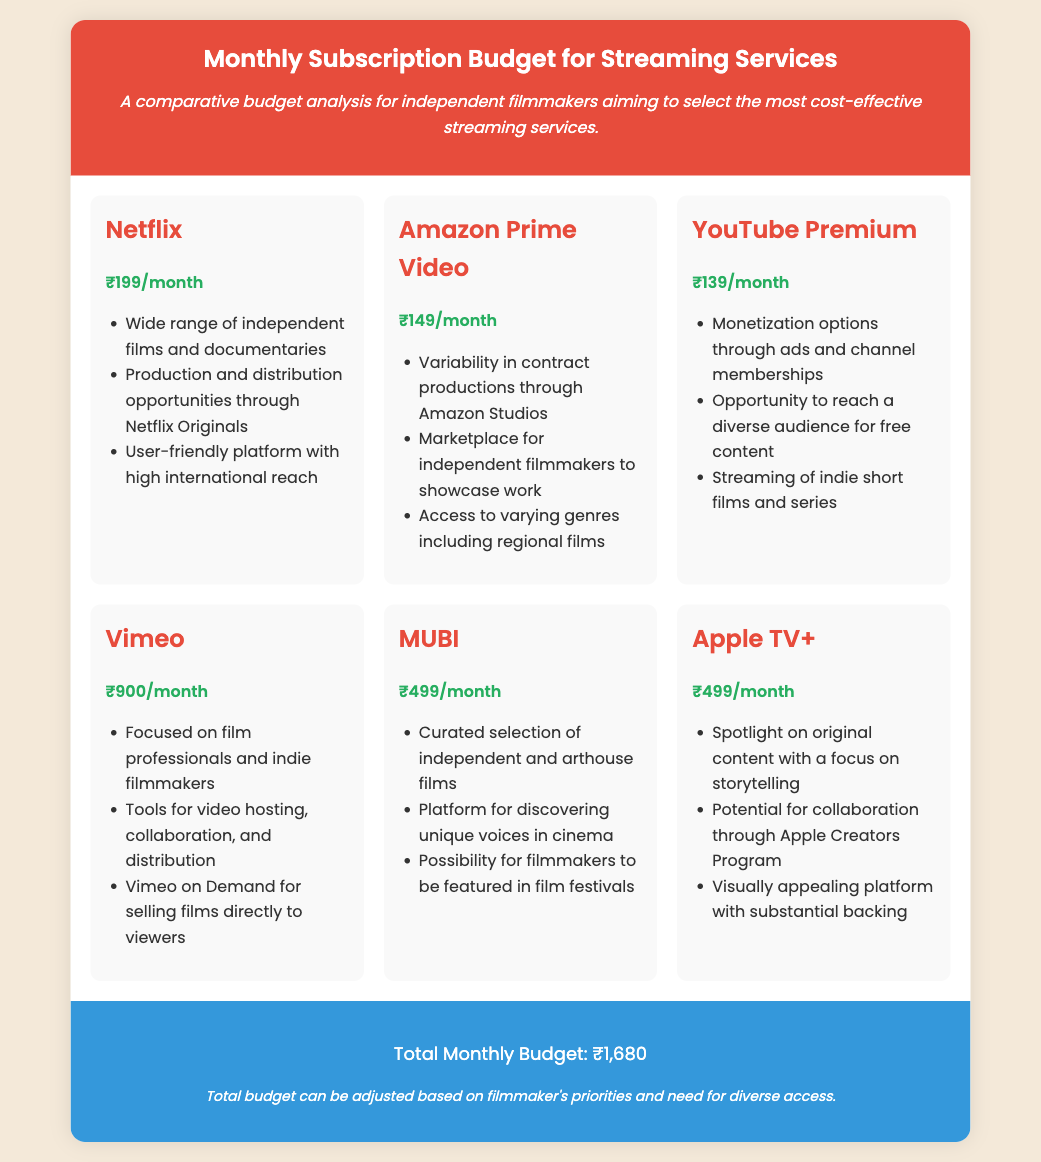What is the subscription cost for Netflix? The subscription cost for Netflix is stated in the document as ₹199/month.
Answer: ₹199/month Which platform offers a marketplace for independent filmmakers? The document mentions Amazon Prime Video as having a marketplace for independent filmmakers.
Answer: Amazon Prime Video What is the total monthly budget for the streaming services? The total monthly budget is provided at the end of the document, which sums the individual subscription costs.
Answer: ₹1,680 Which service has the highest monthly subscription fee? The document lists Vimeo as the service with the highest monthly subscription fee among the options listed.
Answer: ₹900/month How much does YouTube Premium cost? The document specifies that YouTube Premium costs ₹139/month.
Answer: ₹139/month Which streaming service focuses on curated independent films? The document states that MUBI offers a curated selection of independent and arthouse films.
Answer: MUBI What is a reason to choose Vimeo according to the document? The document highlights Vimeo having tools for video hosting, collaboration, and distribution as a key reason for selection.
Answer: Tools for video hosting, collaboration, and distribution How many platforms have a monthly cost of ₹499? The document indicates that two platforms, MUBI and Apple TV+, have a subscription cost of ₹499 each.
Answer: 2 